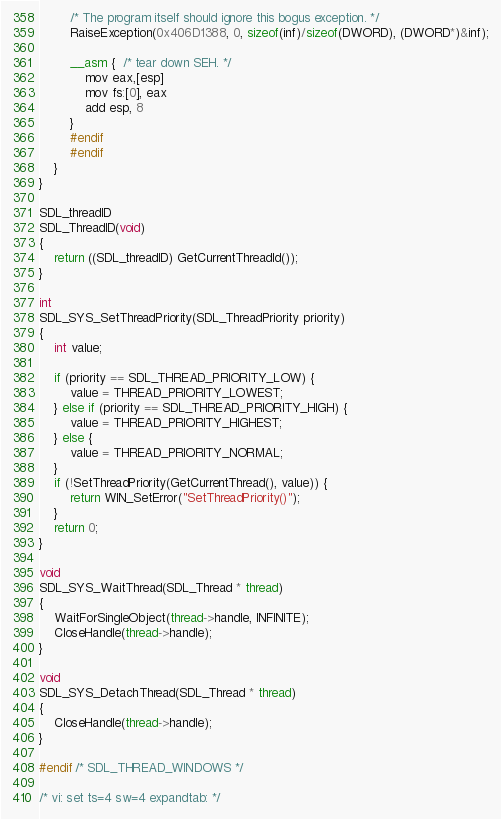<code> <loc_0><loc_0><loc_500><loc_500><_C_>        /* The program itself should ignore this bogus exception. */
        RaiseException(0x406D1388, 0, sizeof(inf)/sizeof(DWORD), (DWORD*)&inf);

        __asm {  /* tear down SEH. */
            mov eax,[esp]
            mov fs:[0], eax
            add esp, 8
        }
        #endif
        #endif
    }
}

SDL_threadID
SDL_ThreadID(void)
{
    return ((SDL_threadID) GetCurrentThreadId());
}

int
SDL_SYS_SetThreadPriority(SDL_ThreadPriority priority)
{
    int value;

    if (priority == SDL_THREAD_PRIORITY_LOW) {
        value = THREAD_PRIORITY_LOWEST;
    } else if (priority == SDL_THREAD_PRIORITY_HIGH) {
        value = THREAD_PRIORITY_HIGHEST;
    } else {
        value = THREAD_PRIORITY_NORMAL;
    }
    if (!SetThreadPriority(GetCurrentThread(), value)) {
        return WIN_SetError("SetThreadPriority()");
    }
    return 0;
}

void
SDL_SYS_WaitThread(SDL_Thread * thread)
{
    WaitForSingleObject(thread->handle, INFINITE);
    CloseHandle(thread->handle);
}

void
SDL_SYS_DetachThread(SDL_Thread * thread)
{
    CloseHandle(thread->handle);
}

#endif /* SDL_THREAD_WINDOWS */

/* vi: set ts=4 sw=4 expandtab: */
</code> 